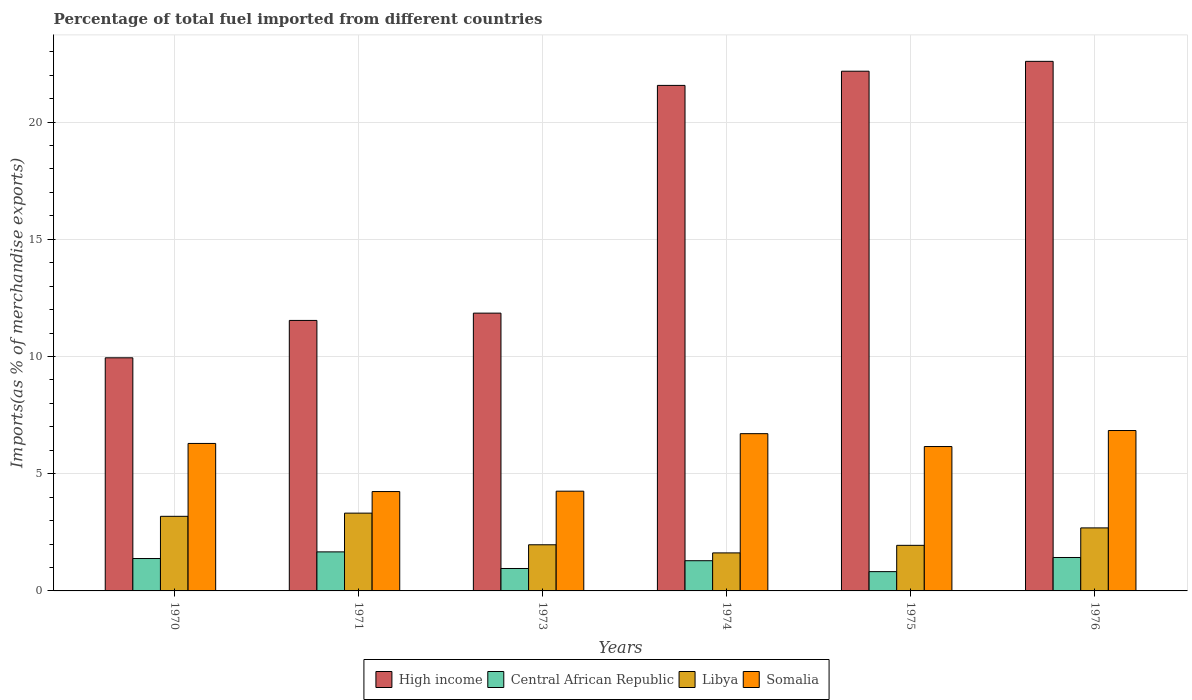How many different coloured bars are there?
Provide a short and direct response. 4. How many groups of bars are there?
Your response must be concise. 6. What is the label of the 5th group of bars from the left?
Provide a succinct answer. 1975. What is the percentage of imports to different countries in High income in 1971?
Your answer should be compact. 11.54. Across all years, what is the maximum percentage of imports to different countries in High income?
Provide a short and direct response. 22.59. Across all years, what is the minimum percentage of imports to different countries in Central African Republic?
Your answer should be compact. 0.82. In which year was the percentage of imports to different countries in High income maximum?
Make the answer very short. 1976. In which year was the percentage of imports to different countries in Central African Republic minimum?
Give a very brief answer. 1975. What is the total percentage of imports to different countries in Libya in the graph?
Offer a terse response. 14.72. What is the difference between the percentage of imports to different countries in Central African Republic in 1970 and that in 1973?
Provide a short and direct response. 0.43. What is the difference between the percentage of imports to different countries in Somalia in 1973 and the percentage of imports to different countries in High income in 1974?
Offer a very short reply. -17.31. What is the average percentage of imports to different countries in High income per year?
Provide a short and direct response. 16.61. In the year 1970, what is the difference between the percentage of imports to different countries in High income and percentage of imports to different countries in Central African Republic?
Provide a succinct answer. 8.56. In how many years, is the percentage of imports to different countries in Central African Republic greater than 4 %?
Ensure brevity in your answer.  0. What is the ratio of the percentage of imports to different countries in Somalia in 1970 to that in 1975?
Provide a succinct answer. 1.02. What is the difference between the highest and the second highest percentage of imports to different countries in Somalia?
Your answer should be compact. 0.13. What is the difference between the highest and the lowest percentage of imports to different countries in High income?
Your answer should be compact. 12.64. In how many years, is the percentage of imports to different countries in High income greater than the average percentage of imports to different countries in High income taken over all years?
Offer a very short reply. 3. What does the 3rd bar from the left in 1976 represents?
Give a very brief answer. Libya. Are all the bars in the graph horizontal?
Make the answer very short. No. What is the difference between two consecutive major ticks on the Y-axis?
Your answer should be compact. 5. Does the graph contain any zero values?
Offer a terse response. No. Does the graph contain grids?
Give a very brief answer. Yes. Where does the legend appear in the graph?
Your answer should be compact. Bottom center. How are the legend labels stacked?
Keep it short and to the point. Horizontal. What is the title of the graph?
Provide a succinct answer. Percentage of total fuel imported from different countries. Does "Lesotho" appear as one of the legend labels in the graph?
Keep it short and to the point. No. What is the label or title of the Y-axis?
Offer a terse response. Imports(as % of merchandise exports). What is the Imports(as % of merchandise exports) of High income in 1970?
Your response must be concise. 9.94. What is the Imports(as % of merchandise exports) in Central African Republic in 1970?
Provide a succinct answer. 1.38. What is the Imports(as % of merchandise exports) in Libya in 1970?
Your answer should be very brief. 3.18. What is the Imports(as % of merchandise exports) in Somalia in 1970?
Your response must be concise. 6.29. What is the Imports(as % of merchandise exports) of High income in 1971?
Ensure brevity in your answer.  11.54. What is the Imports(as % of merchandise exports) in Central African Republic in 1971?
Your answer should be very brief. 1.67. What is the Imports(as % of merchandise exports) of Libya in 1971?
Ensure brevity in your answer.  3.32. What is the Imports(as % of merchandise exports) in Somalia in 1971?
Keep it short and to the point. 4.24. What is the Imports(as % of merchandise exports) in High income in 1973?
Your answer should be compact. 11.85. What is the Imports(as % of merchandise exports) of Central African Republic in 1973?
Keep it short and to the point. 0.96. What is the Imports(as % of merchandise exports) in Libya in 1973?
Keep it short and to the point. 1.97. What is the Imports(as % of merchandise exports) of Somalia in 1973?
Provide a short and direct response. 4.25. What is the Imports(as % of merchandise exports) in High income in 1974?
Ensure brevity in your answer.  21.56. What is the Imports(as % of merchandise exports) of Central African Republic in 1974?
Provide a succinct answer. 1.29. What is the Imports(as % of merchandise exports) in Libya in 1974?
Your answer should be compact. 1.62. What is the Imports(as % of merchandise exports) of Somalia in 1974?
Provide a succinct answer. 6.71. What is the Imports(as % of merchandise exports) in High income in 1975?
Give a very brief answer. 22.17. What is the Imports(as % of merchandise exports) in Central African Republic in 1975?
Give a very brief answer. 0.82. What is the Imports(as % of merchandise exports) in Libya in 1975?
Provide a succinct answer. 1.94. What is the Imports(as % of merchandise exports) of Somalia in 1975?
Your answer should be very brief. 6.16. What is the Imports(as % of merchandise exports) of High income in 1976?
Provide a short and direct response. 22.59. What is the Imports(as % of merchandise exports) in Central African Republic in 1976?
Provide a succinct answer. 1.43. What is the Imports(as % of merchandise exports) of Libya in 1976?
Ensure brevity in your answer.  2.69. What is the Imports(as % of merchandise exports) in Somalia in 1976?
Offer a terse response. 6.84. Across all years, what is the maximum Imports(as % of merchandise exports) in High income?
Provide a short and direct response. 22.59. Across all years, what is the maximum Imports(as % of merchandise exports) of Central African Republic?
Offer a very short reply. 1.67. Across all years, what is the maximum Imports(as % of merchandise exports) in Libya?
Offer a very short reply. 3.32. Across all years, what is the maximum Imports(as % of merchandise exports) in Somalia?
Give a very brief answer. 6.84. Across all years, what is the minimum Imports(as % of merchandise exports) of High income?
Keep it short and to the point. 9.94. Across all years, what is the minimum Imports(as % of merchandise exports) in Central African Republic?
Your response must be concise. 0.82. Across all years, what is the minimum Imports(as % of merchandise exports) of Libya?
Your response must be concise. 1.62. Across all years, what is the minimum Imports(as % of merchandise exports) in Somalia?
Your answer should be very brief. 4.24. What is the total Imports(as % of merchandise exports) in High income in the graph?
Give a very brief answer. 99.65. What is the total Imports(as % of merchandise exports) of Central African Republic in the graph?
Offer a very short reply. 7.54. What is the total Imports(as % of merchandise exports) in Libya in the graph?
Your response must be concise. 14.72. What is the total Imports(as % of merchandise exports) in Somalia in the graph?
Offer a terse response. 34.49. What is the difference between the Imports(as % of merchandise exports) of High income in 1970 and that in 1971?
Your answer should be compact. -1.59. What is the difference between the Imports(as % of merchandise exports) in Central African Republic in 1970 and that in 1971?
Your answer should be very brief. -0.28. What is the difference between the Imports(as % of merchandise exports) of Libya in 1970 and that in 1971?
Make the answer very short. -0.14. What is the difference between the Imports(as % of merchandise exports) of Somalia in 1970 and that in 1971?
Provide a succinct answer. 2.05. What is the difference between the Imports(as % of merchandise exports) in High income in 1970 and that in 1973?
Your response must be concise. -1.91. What is the difference between the Imports(as % of merchandise exports) of Central African Republic in 1970 and that in 1973?
Make the answer very short. 0.43. What is the difference between the Imports(as % of merchandise exports) of Libya in 1970 and that in 1973?
Keep it short and to the point. 1.21. What is the difference between the Imports(as % of merchandise exports) in Somalia in 1970 and that in 1973?
Your answer should be very brief. 2.04. What is the difference between the Imports(as % of merchandise exports) of High income in 1970 and that in 1974?
Offer a very short reply. -11.62. What is the difference between the Imports(as % of merchandise exports) of Central African Republic in 1970 and that in 1974?
Offer a very short reply. 0.09. What is the difference between the Imports(as % of merchandise exports) in Libya in 1970 and that in 1974?
Your response must be concise. 1.56. What is the difference between the Imports(as % of merchandise exports) of Somalia in 1970 and that in 1974?
Provide a succinct answer. -0.42. What is the difference between the Imports(as % of merchandise exports) of High income in 1970 and that in 1975?
Offer a very short reply. -12.22. What is the difference between the Imports(as % of merchandise exports) of Central African Republic in 1970 and that in 1975?
Offer a terse response. 0.56. What is the difference between the Imports(as % of merchandise exports) in Libya in 1970 and that in 1975?
Provide a short and direct response. 1.24. What is the difference between the Imports(as % of merchandise exports) of Somalia in 1970 and that in 1975?
Your response must be concise. 0.13. What is the difference between the Imports(as % of merchandise exports) of High income in 1970 and that in 1976?
Provide a short and direct response. -12.64. What is the difference between the Imports(as % of merchandise exports) in Central African Republic in 1970 and that in 1976?
Your answer should be compact. -0.04. What is the difference between the Imports(as % of merchandise exports) in Libya in 1970 and that in 1976?
Provide a succinct answer. 0.49. What is the difference between the Imports(as % of merchandise exports) in Somalia in 1970 and that in 1976?
Provide a succinct answer. -0.55. What is the difference between the Imports(as % of merchandise exports) in High income in 1971 and that in 1973?
Your answer should be very brief. -0.31. What is the difference between the Imports(as % of merchandise exports) of Central African Republic in 1971 and that in 1973?
Ensure brevity in your answer.  0.71. What is the difference between the Imports(as % of merchandise exports) in Libya in 1971 and that in 1973?
Provide a short and direct response. 1.35. What is the difference between the Imports(as % of merchandise exports) in Somalia in 1971 and that in 1973?
Offer a terse response. -0.02. What is the difference between the Imports(as % of merchandise exports) in High income in 1971 and that in 1974?
Provide a succinct answer. -10.03. What is the difference between the Imports(as % of merchandise exports) in Central African Republic in 1971 and that in 1974?
Ensure brevity in your answer.  0.38. What is the difference between the Imports(as % of merchandise exports) in Libya in 1971 and that in 1974?
Ensure brevity in your answer.  1.7. What is the difference between the Imports(as % of merchandise exports) of Somalia in 1971 and that in 1974?
Provide a succinct answer. -2.47. What is the difference between the Imports(as % of merchandise exports) of High income in 1971 and that in 1975?
Offer a very short reply. -10.63. What is the difference between the Imports(as % of merchandise exports) of Central African Republic in 1971 and that in 1975?
Provide a succinct answer. 0.84. What is the difference between the Imports(as % of merchandise exports) in Libya in 1971 and that in 1975?
Your answer should be very brief. 1.37. What is the difference between the Imports(as % of merchandise exports) in Somalia in 1971 and that in 1975?
Offer a terse response. -1.92. What is the difference between the Imports(as % of merchandise exports) of High income in 1971 and that in 1976?
Offer a very short reply. -11.05. What is the difference between the Imports(as % of merchandise exports) of Central African Republic in 1971 and that in 1976?
Make the answer very short. 0.24. What is the difference between the Imports(as % of merchandise exports) of Libya in 1971 and that in 1976?
Give a very brief answer. 0.63. What is the difference between the Imports(as % of merchandise exports) in Somalia in 1971 and that in 1976?
Make the answer very short. -2.6. What is the difference between the Imports(as % of merchandise exports) of High income in 1973 and that in 1974?
Your answer should be compact. -9.71. What is the difference between the Imports(as % of merchandise exports) of Central African Republic in 1973 and that in 1974?
Offer a very short reply. -0.33. What is the difference between the Imports(as % of merchandise exports) in Libya in 1973 and that in 1974?
Give a very brief answer. 0.35. What is the difference between the Imports(as % of merchandise exports) in Somalia in 1973 and that in 1974?
Provide a short and direct response. -2.45. What is the difference between the Imports(as % of merchandise exports) of High income in 1973 and that in 1975?
Give a very brief answer. -10.32. What is the difference between the Imports(as % of merchandise exports) of Central African Republic in 1973 and that in 1975?
Give a very brief answer. 0.13. What is the difference between the Imports(as % of merchandise exports) of Libya in 1973 and that in 1975?
Give a very brief answer. 0.02. What is the difference between the Imports(as % of merchandise exports) in Somalia in 1973 and that in 1975?
Keep it short and to the point. -1.9. What is the difference between the Imports(as % of merchandise exports) in High income in 1973 and that in 1976?
Make the answer very short. -10.74. What is the difference between the Imports(as % of merchandise exports) in Central African Republic in 1973 and that in 1976?
Your answer should be compact. -0.47. What is the difference between the Imports(as % of merchandise exports) in Libya in 1973 and that in 1976?
Ensure brevity in your answer.  -0.72. What is the difference between the Imports(as % of merchandise exports) of Somalia in 1973 and that in 1976?
Your answer should be very brief. -2.59. What is the difference between the Imports(as % of merchandise exports) in High income in 1974 and that in 1975?
Provide a short and direct response. -0.6. What is the difference between the Imports(as % of merchandise exports) of Central African Republic in 1974 and that in 1975?
Your answer should be very brief. 0.47. What is the difference between the Imports(as % of merchandise exports) in Libya in 1974 and that in 1975?
Keep it short and to the point. -0.32. What is the difference between the Imports(as % of merchandise exports) in Somalia in 1974 and that in 1975?
Your answer should be compact. 0.55. What is the difference between the Imports(as % of merchandise exports) in High income in 1974 and that in 1976?
Ensure brevity in your answer.  -1.03. What is the difference between the Imports(as % of merchandise exports) in Central African Republic in 1974 and that in 1976?
Your answer should be compact. -0.14. What is the difference between the Imports(as % of merchandise exports) in Libya in 1974 and that in 1976?
Provide a short and direct response. -1.07. What is the difference between the Imports(as % of merchandise exports) in Somalia in 1974 and that in 1976?
Make the answer very short. -0.13. What is the difference between the Imports(as % of merchandise exports) of High income in 1975 and that in 1976?
Ensure brevity in your answer.  -0.42. What is the difference between the Imports(as % of merchandise exports) in Central African Republic in 1975 and that in 1976?
Provide a succinct answer. -0.6. What is the difference between the Imports(as % of merchandise exports) of Libya in 1975 and that in 1976?
Keep it short and to the point. -0.74. What is the difference between the Imports(as % of merchandise exports) in Somalia in 1975 and that in 1976?
Give a very brief answer. -0.68. What is the difference between the Imports(as % of merchandise exports) of High income in 1970 and the Imports(as % of merchandise exports) of Central African Republic in 1971?
Your answer should be very brief. 8.28. What is the difference between the Imports(as % of merchandise exports) in High income in 1970 and the Imports(as % of merchandise exports) in Libya in 1971?
Your answer should be very brief. 6.63. What is the difference between the Imports(as % of merchandise exports) of High income in 1970 and the Imports(as % of merchandise exports) of Somalia in 1971?
Your answer should be very brief. 5.71. What is the difference between the Imports(as % of merchandise exports) in Central African Republic in 1970 and the Imports(as % of merchandise exports) in Libya in 1971?
Make the answer very short. -1.94. What is the difference between the Imports(as % of merchandise exports) of Central African Republic in 1970 and the Imports(as % of merchandise exports) of Somalia in 1971?
Ensure brevity in your answer.  -2.86. What is the difference between the Imports(as % of merchandise exports) in Libya in 1970 and the Imports(as % of merchandise exports) in Somalia in 1971?
Ensure brevity in your answer.  -1.06. What is the difference between the Imports(as % of merchandise exports) in High income in 1970 and the Imports(as % of merchandise exports) in Central African Republic in 1973?
Your answer should be compact. 8.99. What is the difference between the Imports(as % of merchandise exports) in High income in 1970 and the Imports(as % of merchandise exports) in Libya in 1973?
Offer a very short reply. 7.98. What is the difference between the Imports(as % of merchandise exports) in High income in 1970 and the Imports(as % of merchandise exports) in Somalia in 1973?
Your answer should be very brief. 5.69. What is the difference between the Imports(as % of merchandise exports) in Central African Republic in 1970 and the Imports(as % of merchandise exports) in Libya in 1973?
Ensure brevity in your answer.  -0.59. What is the difference between the Imports(as % of merchandise exports) in Central African Republic in 1970 and the Imports(as % of merchandise exports) in Somalia in 1973?
Ensure brevity in your answer.  -2.87. What is the difference between the Imports(as % of merchandise exports) of Libya in 1970 and the Imports(as % of merchandise exports) of Somalia in 1973?
Your answer should be very brief. -1.07. What is the difference between the Imports(as % of merchandise exports) in High income in 1970 and the Imports(as % of merchandise exports) in Central African Republic in 1974?
Your response must be concise. 8.65. What is the difference between the Imports(as % of merchandise exports) in High income in 1970 and the Imports(as % of merchandise exports) in Libya in 1974?
Offer a terse response. 8.32. What is the difference between the Imports(as % of merchandise exports) of High income in 1970 and the Imports(as % of merchandise exports) of Somalia in 1974?
Your answer should be very brief. 3.24. What is the difference between the Imports(as % of merchandise exports) in Central African Republic in 1970 and the Imports(as % of merchandise exports) in Libya in 1974?
Your answer should be very brief. -0.24. What is the difference between the Imports(as % of merchandise exports) in Central African Republic in 1970 and the Imports(as % of merchandise exports) in Somalia in 1974?
Your response must be concise. -5.33. What is the difference between the Imports(as % of merchandise exports) in Libya in 1970 and the Imports(as % of merchandise exports) in Somalia in 1974?
Give a very brief answer. -3.53. What is the difference between the Imports(as % of merchandise exports) in High income in 1970 and the Imports(as % of merchandise exports) in Central African Republic in 1975?
Provide a short and direct response. 9.12. What is the difference between the Imports(as % of merchandise exports) in High income in 1970 and the Imports(as % of merchandise exports) in Libya in 1975?
Your response must be concise. 8. What is the difference between the Imports(as % of merchandise exports) of High income in 1970 and the Imports(as % of merchandise exports) of Somalia in 1975?
Give a very brief answer. 3.79. What is the difference between the Imports(as % of merchandise exports) of Central African Republic in 1970 and the Imports(as % of merchandise exports) of Libya in 1975?
Give a very brief answer. -0.56. What is the difference between the Imports(as % of merchandise exports) in Central African Republic in 1970 and the Imports(as % of merchandise exports) in Somalia in 1975?
Provide a succinct answer. -4.78. What is the difference between the Imports(as % of merchandise exports) in Libya in 1970 and the Imports(as % of merchandise exports) in Somalia in 1975?
Your response must be concise. -2.98. What is the difference between the Imports(as % of merchandise exports) in High income in 1970 and the Imports(as % of merchandise exports) in Central African Republic in 1976?
Make the answer very short. 8.52. What is the difference between the Imports(as % of merchandise exports) of High income in 1970 and the Imports(as % of merchandise exports) of Libya in 1976?
Provide a short and direct response. 7.26. What is the difference between the Imports(as % of merchandise exports) in High income in 1970 and the Imports(as % of merchandise exports) in Somalia in 1976?
Ensure brevity in your answer.  3.1. What is the difference between the Imports(as % of merchandise exports) in Central African Republic in 1970 and the Imports(as % of merchandise exports) in Libya in 1976?
Offer a terse response. -1.31. What is the difference between the Imports(as % of merchandise exports) of Central African Republic in 1970 and the Imports(as % of merchandise exports) of Somalia in 1976?
Give a very brief answer. -5.46. What is the difference between the Imports(as % of merchandise exports) of Libya in 1970 and the Imports(as % of merchandise exports) of Somalia in 1976?
Offer a very short reply. -3.66. What is the difference between the Imports(as % of merchandise exports) of High income in 1971 and the Imports(as % of merchandise exports) of Central African Republic in 1973?
Keep it short and to the point. 10.58. What is the difference between the Imports(as % of merchandise exports) in High income in 1971 and the Imports(as % of merchandise exports) in Libya in 1973?
Your response must be concise. 9.57. What is the difference between the Imports(as % of merchandise exports) in High income in 1971 and the Imports(as % of merchandise exports) in Somalia in 1973?
Provide a short and direct response. 7.28. What is the difference between the Imports(as % of merchandise exports) of Central African Republic in 1971 and the Imports(as % of merchandise exports) of Libya in 1973?
Offer a very short reply. -0.3. What is the difference between the Imports(as % of merchandise exports) in Central African Republic in 1971 and the Imports(as % of merchandise exports) in Somalia in 1973?
Provide a succinct answer. -2.59. What is the difference between the Imports(as % of merchandise exports) of Libya in 1971 and the Imports(as % of merchandise exports) of Somalia in 1973?
Provide a short and direct response. -0.94. What is the difference between the Imports(as % of merchandise exports) in High income in 1971 and the Imports(as % of merchandise exports) in Central African Republic in 1974?
Your answer should be compact. 10.25. What is the difference between the Imports(as % of merchandise exports) of High income in 1971 and the Imports(as % of merchandise exports) of Libya in 1974?
Give a very brief answer. 9.92. What is the difference between the Imports(as % of merchandise exports) of High income in 1971 and the Imports(as % of merchandise exports) of Somalia in 1974?
Your answer should be compact. 4.83. What is the difference between the Imports(as % of merchandise exports) of Central African Republic in 1971 and the Imports(as % of merchandise exports) of Libya in 1974?
Keep it short and to the point. 0.04. What is the difference between the Imports(as % of merchandise exports) of Central African Republic in 1971 and the Imports(as % of merchandise exports) of Somalia in 1974?
Provide a succinct answer. -5.04. What is the difference between the Imports(as % of merchandise exports) of Libya in 1971 and the Imports(as % of merchandise exports) of Somalia in 1974?
Give a very brief answer. -3.39. What is the difference between the Imports(as % of merchandise exports) of High income in 1971 and the Imports(as % of merchandise exports) of Central African Republic in 1975?
Keep it short and to the point. 10.72. What is the difference between the Imports(as % of merchandise exports) in High income in 1971 and the Imports(as % of merchandise exports) in Libya in 1975?
Provide a short and direct response. 9.59. What is the difference between the Imports(as % of merchandise exports) in High income in 1971 and the Imports(as % of merchandise exports) in Somalia in 1975?
Offer a terse response. 5.38. What is the difference between the Imports(as % of merchandise exports) of Central African Republic in 1971 and the Imports(as % of merchandise exports) of Libya in 1975?
Your answer should be compact. -0.28. What is the difference between the Imports(as % of merchandise exports) of Central African Republic in 1971 and the Imports(as % of merchandise exports) of Somalia in 1975?
Give a very brief answer. -4.49. What is the difference between the Imports(as % of merchandise exports) of Libya in 1971 and the Imports(as % of merchandise exports) of Somalia in 1975?
Make the answer very short. -2.84. What is the difference between the Imports(as % of merchandise exports) in High income in 1971 and the Imports(as % of merchandise exports) in Central African Republic in 1976?
Keep it short and to the point. 10.11. What is the difference between the Imports(as % of merchandise exports) in High income in 1971 and the Imports(as % of merchandise exports) in Libya in 1976?
Keep it short and to the point. 8.85. What is the difference between the Imports(as % of merchandise exports) in High income in 1971 and the Imports(as % of merchandise exports) in Somalia in 1976?
Your answer should be compact. 4.7. What is the difference between the Imports(as % of merchandise exports) in Central African Republic in 1971 and the Imports(as % of merchandise exports) in Libya in 1976?
Offer a very short reply. -1.02. What is the difference between the Imports(as % of merchandise exports) of Central African Republic in 1971 and the Imports(as % of merchandise exports) of Somalia in 1976?
Your response must be concise. -5.18. What is the difference between the Imports(as % of merchandise exports) in Libya in 1971 and the Imports(as % of merchandise exports) in Somalia in 1976?
Make the answer very short. -3.52. What is the difference between the Imports(as % of merchandise exports) of High income in 1973 and the Imports(as % of merchandise exports) of Central African Republic in 1974?
Your answer should be compact. 10.56. What is the difference between the Imports(as % of merchandise exports) of High income in 1973 and the Imports(as % of merchandise exports) of Libya in 1974?
Provide a short and direct response. 10.23. What is the difference between the Imports(as % of merchandise exports) of High income in 1973 and the Imports(as % of merchandise exports) of Somalia in 1974?
Provide a succinct answer. 5.14. What is the difference between the Imports(as % of merchandise exports) in Central African Republic in 1973 and the Imports(as % of merchandise exports) in Libya in 1974?
Your answer should be compact. -0.67. What is the difference between the Imports(as % of merchandise exports) of Central African Republic in 1973 and the Imports(as % of merchandise exports) of Somalia in 1974?
Provide a succinct answer. -5.75. What is the difference between the Imports(as % of merchandise exports) of Libya in 1973 and the Imports(as % of merchandise exports) of Somalia in 1974?
Offer a terse response. -4.74. What is the difference between the Imports(as % of merchandise exports) in High income in 1973 and the Imports(as % of merchandise exports) in Central African Republic in 1975?
Offer a very short reply. 11.03. What is the difference between the Imports(as % of merchandise exports) of High income in 1973 and the Imports(as % of merchandise exports) of Libya in 1975?
Keep it short and to the point. 9.9. What is the difference between the Imports(as % of merchandise exports) in High income in 1973 and the Imports(as % of merchandise exports) in Somalia in 1975?
Ensure brevity in your answer.  5.69. What is the difference between the Imports(as % of merchandise exports) of Central African Republic in 1973 and the Imports(as % of merchandise exports) of Libya in 1975?
Ensure brevity in your answer.  -0.99. What is the difference between the Imports(as % of merchandise exports) in Central African Republic in 1973 and the Imports(as % of merchandise exports) in Somalia in 1975?
Keep it short and to the point. -5.2. What is the difference between the Imports(as % of merchandise exports) in Libya in 1973 and the Imports(as % of merchandise exports) in Somalia in 1975?
Give a very brief answer. -4.19. What is the difference between the Imports(as % of merchandise exports) of High income in 1973 and the Imports(as % of merchandise exports) of Central African Republic in 1976?
Make the answer very short. 10.42. What is the difference between the Imports(as % of merchandise exports) in High income in 1973 and the Imports(as % of merchandise exports) in Libya in 1976?
Ensure brevity in your answer.  9.16. What is the difference between the Imports(as % of merchandise exports) in High income in 1973 and the Imports(as % of merchandise exports) in Somalia in 1976?
Your answer should be very brief. 5.01. What is the difference between the Imports(as % of merchandise exports) of Central African Republic in 1973 and the Imports(as % of merchandise exports) of Libya in 1976?
Your answer should be compact. -1.73. What is the difference between the Imports(as % of merchandise exports) of Central African Republic in 1973 and the Imports(as % of merchandise exports) of Somalia in 1976?
Keep it short and to the point. -5.88. What is the difference between the Imports(as % of merchandise exports) of Libya in 1973 and the Imports(as % of merchandise exports) of Somalia in 1976?
Your answer should be compact. -4.87. What is the difference between the Imports(as % of merchandise exports) in High income in 1974 and the Imports(as % of merchandise exports) in Central African Republic in 1975?
Ensure brevity in your answer.  20.74. What is the difference between the Imports(as % of merchandise exports) of High income in 1974 and the Imports(as % of merchandise exports) of Libya in 1975?
Provide a short and direct response. 19.62. What is the difference between the Imports(as % of merchandise exports) of High income in 1974 and the Imports(as % of merchandise exports) of Somalia in 1975?
Keep it short and to the point. 15.4. What is the difference between the Imports(as % of merchandise exports) of Central African Republic in 1974 and the Imports(as % of merchandise exports) of Libya in 1975?
Provide a short and direct response. -0.66. What is the difference between the Imports(as % of merchandise exports) of Central African Republic in 1974 and the Imports(as % of merchandise exports) of Somalia in 1975?
Give a very brief answer. -4.87. What is the difference between the Imports(as % of merchandise exports) of Libya in 1974 and the Imports(as % of merchandise exports) of Somalia in 1975?
Make the answer very short. -4.54. What is the difference between the Imports(as % of merchandise exports) of High income in 1974 and the Imports(as % of merchandise exports) of Central African Republic in 1976?
Your response must be concise. 20.14. What is the difference between the Imports(as % of merchandise exports) in High income in 1974 and the Imports(as % of merchandise exports) in Libya in 1976?
Your answer should be very brief. 18.87. What is the difference between the Imports(as % of merchandise exports) of High income in 1974 and the Imports(as % of merchandise exports) of Somalia in 1976?
Your answer should be very brief. 14.72. What is the difference between the Imports(as % of merchandise exports) of Central African Republic in 1974 and the Imports(as % of merchandise exports) of Libya in 1976?
Your response must be concise. -1.4. What is the difference between the Imports(as % of merchandise exports) of Central African Republic in 1974 and the Imports(as % of merchandise exports) of Somalia in 1976?
Provide a short and direct response. -5.55. What is the difference between the Imports(as % of merchandise exports) of Libya in 1974 and the Imports(as % of merchandise exports) of Somalia in 1976?
Provide a short and direct response. -5.22. What is the difference between the Imports(as % of merchandise exports) of High income in 1975 and the Imports(as % of merchandise exports) of Central African Republic in 1976?
Ensure brevity in your answer.  20.74. What is the difference between the Imports(as % of merchandise exports) of High income in 1975 and the Imports(as % of merchandise exports) of Libya in 1976?
Your answer should be very brief. 19.48. What is the difference between the Imports(as % of merchandise exports) in High income in 1975 and the Imports(as % of merchandise exports) in Somalia in 1976?
Give a very brief answer. 15.33. What is the difference between the Imports(as % of merchandise exports) of Central African Republic in 1975 and the Imports(as % of merchandise exports) of Libya in 1976?
Provide a short and direct response. -1.87. What is the difference between the Imports(as % of merchandise exports) in Central African Republic in 1975 and the Imports(as % of merchandise exports) in Somalia in 1976?
Provide a short and direct response. -6.02. What is the difference between the Imports(as % of merchandise exports) of Libya in 1975 and the Imports(as % of merchandise exports) of Somalia in 1976?
Your answer should be compact. -4.9. What is the average Imports(as % of merchandise exports) of High income per year?
Keep it short and to the point. 16.61. What is the average Imports(as % of merchandise exports) of Central African Republic per year?
Your response must be concise. 1.26. What is the average Imports(as % of merchandise exports) of Libya per year?
Provide a succinct answer. 2.45. What is the average Imports(as % of merchandise exports) of Somalia per year?
Your response must be concise. 5.75. In the year 1970, what is the difference between the Imports(as % of merchandise exports) in High income and Imports(as % of merchandise exports) in Central African Republic?
Give a very brief answer. 8.56. In the year 1970, what is the difference between the Imports(as % of merchandise exports) of High income and Imports(as % of merchandise exports) of Libya?
Your answer should be compact. 6.76. In the year 1970, what is the difference between the Imports(as % of merchandise exports) of High income and Imports(as % of merchandise exports) of Somalia?
Provide a short and direct response. 3.65. In the year 1970, what is the difference between the Imports(as % of merchandise exports) in Central African Republic and Imports(as % of merchandise exports) in Libya?
Your response must be concise. -1.8. In the year 1970, what is the difference between the Imports(as % of merchandise exports) in Central African Republic and Imports(as % of merchandise exports) in Somalia?
Your answer should be very brief. -4.91. In the year 1970, what is the difference between the Imports(as % of merchandise exports) in Libya and Imports(as % of merchandise exports) in Somalia?
Offer a very short reply. -3.11. In the year 1971, what is the difference between the Imports(as % of merchandise exports) in High income and Imports(as % of merchandise exports) in Central African Republic?
Provide a succinct answer. 9.87. In the year 1971, what is the difference between the Imports(as % of merchandise exports) of High income and Imports(as % of merchandise exports) of Libya?
Provide a short and direct response. 8.22. In the year 1971, what is the difference between the Imports(as % of merchandise exports) of High income and Imports(as % of merchandise exports) of Somalia?
Ensure brevity in your answer.  7.3. In the year 1971, what is the difference between the Imports(as % of merchandise exports) of Central African Republic and Imports(as % of merchandise exports) of Libya?
Give a very brief answer. -1.65. In the year 1971, what is the difference between the Imports(as % of merchandise exports) in Central African Republic and Imports(as % of merchandise exports) in Somalia?
Offer a terse response. -2.57. In the year 1971, what is the difference between the Imports(as % of merchandise exports) in Libya and Imports(as % of merchandise exports) in Somalia?
Ensure brevity in your answer.  -0.92. In the year 1973, what is the difference between the Imports(as % of merchandise exports) of High income and Imports(as % of merchandise exports) of Central African Republic?
Keep it short and to the point. 10.89. In the year 1973, what is the difference between the Imports(as % of merchandise exports) in High income and Imports(as % of merchandise exports) in Libya?
Your response must be concise. 9.88. In the year 1973, what is the difference between the Imports(as % of merchandise exports) of High income and Imports(as % of merchandise exports) of Somalia?
Make the answer very short. 7.59. In the year 1973, what is the difference between the Imports(as % of merchandise exports) in Central African Republic and Imports(as % of merchandise exports) in Libya?
Make the answer very short. -1.01. In the year 1973, what is the difference between the Imports(as % of merchandise exports) of Central African Republic and Imports(as % of merchandise exports) of Somalia?
Keep it short and to the point. -3.3. In the year 1973, what is the difference between the Imports(as % of merchandise exports) in Libya and Imports(as % of merchandise exports) in Somalia?
Keep it short and to the point. -2.29. In the year 1974, what is the difference between the Imports(as % of merchandise exports) in High income and Imports(as % of merchandise exports) in Central African Republic?
Give a very brief answer. 20.27. In the year 1974, what is the difference between the Imports(as % of merchandise exports) in High income and Imports(as % of merchandise exports) in Libya?
Offer a terse response. 19.94. In the year 1974, what is the difference between the Imports(as % of merchandise exports) in High income and Imports(as % of merchandise exports) in Somalia?
Ensure brevity in your answer.  14.85. In the year 1974, what is the difference between the Imports(as % of merchandise exports) of Central African Republic and Imports(as % of merchandise exports) of Libya?
Provide a short and direct response. -0.33. In the year 1974, what is the difference between the Imports(as % of merchandise exports) of Central African Republic and Imports(as % of merchandise exports) of Somalia?
Give a very brief answer. -5.42. In the year 1974, what is the difference between the Imports(as % of merchandise exports) in Libya and Imports(as % of merchandise exports) in Somalia?
Your answer should be compact. -5.09. In the year 1975, what is the difference between the Imports(as % of merchandise exports) in High income and Imports(as % of merchandise exports) in Central African Republic?
Make the answer very short. 21.35. In the year 1975, what is the difference between the Imports(as % of merchandise exports) in High income and Imports(as % of merchandise exports) in Libya?
Your answer should be compact. 20.22. In the year 1975, what is the difference between the Imports(as % of merchandise exports) in High income and Imports(as % of merchandise exports) in Somalia?
Ensure brevity in your answer.  16.01. In the year 1975, what is the difference between the Imports(as % of merchandise exports) in Central African Republic and Imports(as % of merchandise exports) in Libya?
Make the answer very short. -1.12. In the year 1975, what is the difference between the Imports(as % of merchandise exports) of Central African Republic and Imports(as % of merchandise exports) of Somalia?
Keep it short and to the point. -5.34. In the year 1975, what is the difference between the Imports(as % of merchandise exports) of Libya and Imports(as % of merchandise exports) of Somalia?
Offer a terse response. -4.21. In the year 1976, what is the difference between the Imports(as % of merchandise exports) of High income and Imports(as % of merchandise exports) of Central African Republic?
Provide a succinct answer. 21.16. In the year 1976, what is the difference between the Imports(as % of merchandise exports) in High income and Imports(as % of merchandise exports) in Libya?
Give a very brief answer. 19.9. In the year 1976, what is the difference between the Imports(as % of merchandise exports) of High income and Imports(as % of merchandise exports) of Somalia?
Keep it short and to the point. 15.75. In the year 1976, what is the difference between the Imports(as % of merchandise exports) of Central African Republic and Imports(as % of merchandise exports) of Libya?
Ensure brevity in your answer.  -1.26. In the year 1976, what is the difference between the Imports(as % of merchandise exports) in Central African Republic and Imports(as % of merchandise exports) in Somalia?
Ensure brevity in your answer.  -5.42. In the year 1976, what is the difference between the Imports(as % of merchandise exports) in Libya and Imports(as % of merchandise exports) in Somalia?
Make the answer very short. -4.15. What is the ratio of the Imports(as % of merchandise exports) of High income in 1970 to that in 1971?
Give a very brief answer. 0.86. What is the ratio of the Imports(as % of merchandise exports) in Central African Republic in 1970 to that in 1971?
Your answer should be compact. 0.83. What is the ratio of the Imports(as % of merchandise exports) in Somalia in 1970 to that in 1971?
Your response must be concise. 1.48. What is the ratio of the Imports(as % of merchandise exports) of High income in 1970 to that in 1973?
Offer a terse response. 0.84. What is the ratio of the Imports(as % of merchandise exports) in Central African Republic in 1970 to that in 1973?
Offer a very short reply. 1.44. What is the ratio of the Imports(as % of merchandise exports) of Libya in 1970 to that in 1973?
Ensure brevity in your answer.  1.62. What is the ratio of the Imports(as % of merchandise exports) in Somalia in 1970 to that in 1973?
Keep it short and to the point. 1.48. What is the ratio of the Imports(as % of merchandise exports) of High income in 1970 to that in 1974?
Ensure brevity in your answer.  0.46. What is the ratio of the Imports(as % of merchandise exports) in Central African Republic in 1970 to that in 1974?
Your response must be concise. 1.07. What is the ratio of the Imports(as % of merchandise exports) in Libya in 1970 to that in 1974?
Provide a succinct answer. 1.96. What is the ratio of the Imports(as % of merchandise exports) of Somalia in 1970 to that in 1974?
Give a very brief answer. 0.94. What is the ratio of the Imports(as % of merchandise exports) of High income in 1970 to that in 1975?
Your answer should be very brief. 0.45. What is the ratio of the Imports(as % of merchandise exports) of Central African Republic in 1970 to that in 1975?
Give a very brief answer. 1.68. What is the ratio of the Imports(as % of merchandise exports) in Libya in 1970 to that in 1975?
Your answer should be very brief. 1.64. What is the ratio of the Imports(as % of merchandise exports) of Somalia in 1970 to that in 1975?
Offer a very short reply. 1.02. What is the ratio of the Imports(as % of merchandise exports) of High income in 1970 to that in 1976?
Your answer should be very brief. 0.44. What is the ratio of the Imports(as % of merchandise exports) of Central African Republic in 1970 to that in 1976?
Your answer should be compact. 0.97. What is the ratio of the Imports(as % of merchandise exports) of Libya in 1970 to that in 1976?
Offer a very short reply. 1.18. What is the ratio of the Imports(as % of merchandise exports) of Somalia in 1970 to that in 1976?
Provide a succinct answer. 0.92. What is the ratio of the Imports(as % of merchandise exports) in High income in 1971 to that in 1973?
Your response must be concise. 0.97. What is the ratio of the Imports(as % of merchandise exports) of Central African Republic in 1971 to that in 1973?
Give a very brief answer. 1.74. What is the ratio of the Imports(as % of merchandise exports) in Libya in 1971 to that in 1973?
Make the answer very short. 1.69. What is the ratio of the Imports(as % of merchandise exports) in High income in 1971 to that in 1974?
Your response must be concise. 0.54. What is the ratio of the Imports(as % of merchandise exports) in Central African Republic in 1971 to that in 1974?
Offer a terse response. 1.29. What is the ratio of the Imports(as % of merchandise exports) in Libya in 1971 to that in 1974?
Provide a short and direct response. 2.05. What is the ratio of the Imports(as % of merchandise exports) in Somalia in 1971 to that in 1974?
Offer a very short reply. 0.63. What is the ratio of the Imports(as % of merchandise exports) of High income in 1971 to that in 1975?
Offer a terse response. 0.52. What is the ratio of the Imports(as % of merchandise exports) of Central African Republic in 1971 to that in 1975?
Provide a succinct answer. 2.02. What is the ratio of the Imports(as % of merchandise exports) in Libya in 1971 to that in 1975?
Your response must be concise. 1.71. What is the ratio of the Imports(as % of merchandise exports) in Somalia in 1971 to that in 1975?
Ensure brevity in your answer.  0.69. What is the ratio of the Imports(as % of merchandise exports) in High income in 1971 to that in 1976?
Provide a succinct answer. 0.51. What is the ratio of the Imports(as % of merchandise exports) of Central African Republic in 1971 to that in 1976?
Offer a terse response. 1.17. What is the ratio of the Imports(as % of merchandise exports) in Libya in 1971 to that in 1976?
Your answer should be compact. 1.23. What is the ratio of the Imports(as % of merchandise exports) in Somalia in 1971 to that in 1976?
Offer a terse response. 0.62. What is the ratio of the Imports(as % of merchandise exports) in High income in 1973 to that in 1974?
Your response must be concise. 0.55. What is the ratio of the Imports(as % of merchandise exports) in Central African Republic in 1973 to that in 1974?
Offer a very short reply. 0.74. What is the ratio of the Imports(as % of merchandise exports) of Libya in 1973 to that in 1974?
Ensure brevity in your answer.  1.21. What is the ratio of the Imports(as % of merchandise exports) of Somalia in 1973 to that in 1974?
Provide a succinct answer. 0.63. What is the ratio of the Imports(as % of merchandise exports) of High income in 1973 to that in 1975?
Your response must be concise. 0.53. What is the ratio of the Imports(as % of merchandise exports) of Central African Republic in 1973 to that in 1975?
Give a very brief answer. 1.16. What is the ratio of the Imports(as % of merchandise exports) of Libya in 1973 to that in 1975?
Keep it short and to the point. 1.01. What is the ratio of the Imports(as % of merchandise exports) in Somalia in 1973 to that in 1975?
Provide a succinct answer. 0.69. What is the ratio of the Imports(as % of merchandise exports) of High income in 1973 to that in 1976?
Keep it short and to the point. 0.52. What is the ratio of the Imports(as % of merchandise exports) in Central African Republic in 1973 to that in 1976?
Your answer should be compact. 0.67. What is the ratio of the Imports(as % of merchandise exports) in Libya in 1973 to that in 1976?
Provide a succinct answer. 0.73. What is the ratio of the Imports(as % of merchandise exports) in Somalia in 1973 to that in 1976?
Offer a very short reply. 0.62. What is the ratio of the Imports(as % of merchandise exports) of High income in 1974 to that in 1975?
Give a very brief answer. 0.97. What is the ratio of the Imports(as % of merchandise exports) in Central African Republic in 1974 to that in 1975?
Ensure brevity in your answer.  1.57. What is the ratio of the Imports(as % of merchandise exports) of Libya in 1974 to that in 1975?
Offer a terse response. 0.83. What is the ratio of the Imports(as % of merchandise exports) of Somalia in 1974 to that in 1975?
Your response must be concise. 1.09. What is the ratio of the Imports(as % of merchandise exports) in High income in 1974 to that in 1976?
Provide a succinct answer. 0.95. What is the ratio of the Imports(as % of merchandise exports) in Central African Republic in 1974 to that in 1976?
Provide a succinct answer. 0.9. What is the ratio of the Imports(as % of merchandise exports) in Libya in 1974 to that in 1976?
Make the answer very short. 0.6. What is the ratio of the Imports(as % of merchandise exports) in Somalia in 1974 to that in 1976?
Your answer should be compact. 0.98. What is the ratio of the Imports(as % of merchandise exports) of High income in 1975 to that in 1976?
Your answer should be very brief. 0.98. What is the ratio of the Imports(as % of merchandise exports) in Central African Republic in 1975 to that in 1976?
Your answer should be very brief. 0.58. What is the ratio of the Imports(as % of merchandise exports) of Libya in 1975 to that in 1976?
Give a very brief answer. 0.72. What is the ratio of the Imports(as % of merchandise exports) in Somalia in 1975 to that in 1976?
Make the answer very short. 0.9. What is the difference between the highest and the second highest Imports(as % of merchandise exports) in High income?
Offer a very short reply. 0.42. What is the difference between the highest and the second highest Imports(as % of merchandise exports) in Central African Republic?
Keep it short and to the point. 0.24. What is the difference between the highest and the second highest Imports(as % of merchandise exports) of Libya?
Ensure brevity in your answer.  0.14. What is the difference between the highest and the second highest Imports(as % of merchandise exports) in Somalia?
Your response must be concise. 0.13. What is the difference between the highest and the lowest Imports(as % of merchandise exports) in High income?
Give a very brief answer. 12.64. What is the difference between the highest and the lowest Imports(as % of merchandise exports) in Central African Republic?
Provide a succinct answer. 0.84. What is the difference between the highest and the lowest Imports(as % of merchandise exports) of Libya?
Keep it short and to the point. 1.7. What is the difference between the highest and the lowest Imports(as % of merchandise exports) in Somalia?
Offer a very short reply. 2.6. 